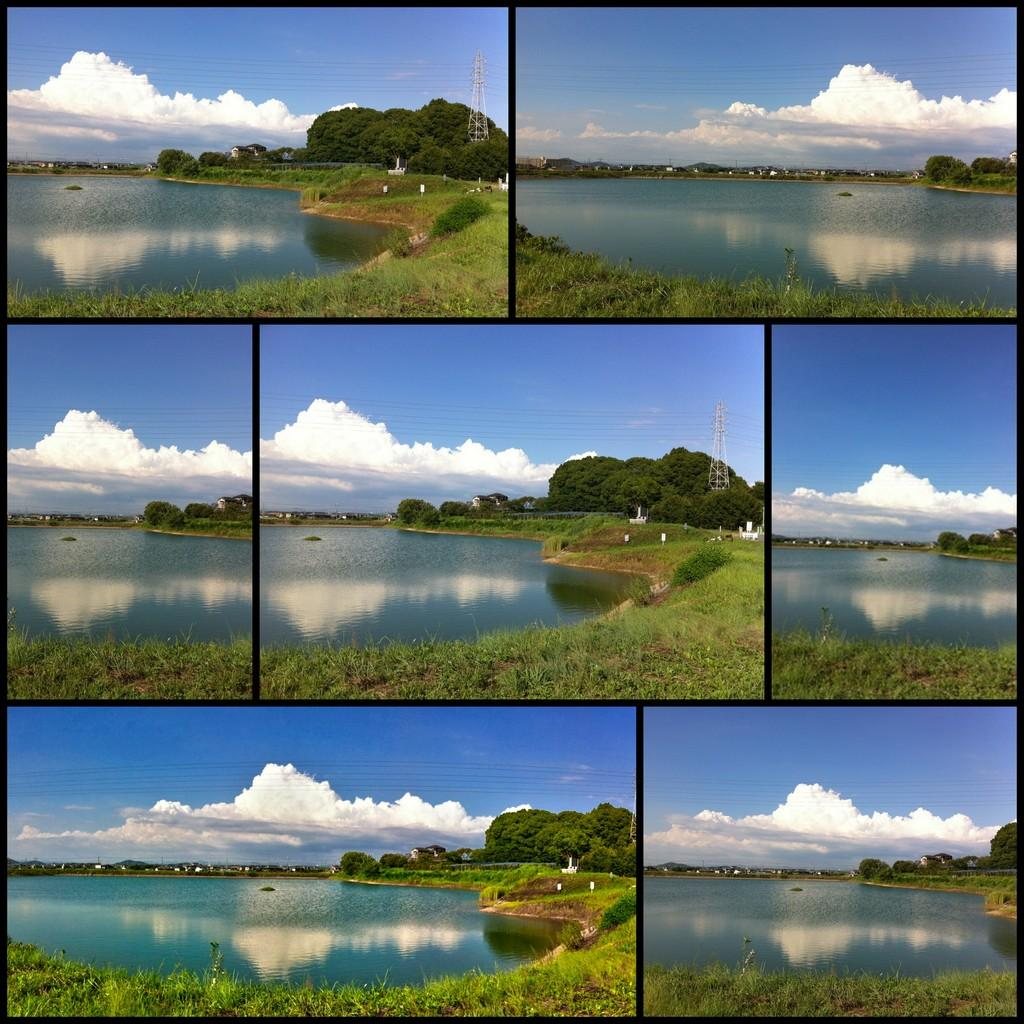What type of images are present in the collage? The image contains collage photos. What natural elements can be seen in the collage photos? Water, grass, trees, and clouds are visible in the collage photos. What man-made structures are present in the collage photos? Wires and towers are present in the collage photos. What part of the sky is visible in the collage photos? The sky is visible in the collage photos. How many children are playing with the egg and skirt in the collage photos? There are no children, eggs, or skirts present in the collage photos. 